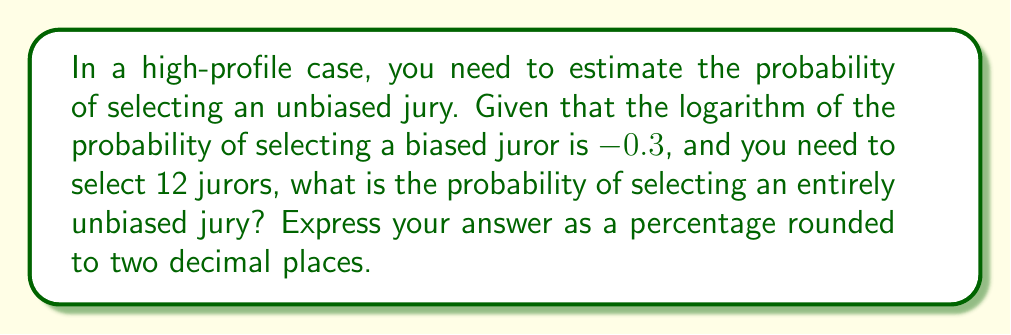Give your solution to this math problem. Let's approach this step-by-step:

1) First, we need to find the probability of selecting a biased juror. We're given that:

   $\log(P(\text{biased})) = -0.3$

2) To find $P(\text{biased})$, we need to take the antilog (inverse of log):

   $P(\text{biased}) = 10^{-0.3} \approx 0.5012$

3) The probability of selecting an unbiased juror is therefore:

   $P(\text{unbiased}) = 1 - P(\text{biased}) \approx 1 - 0.5012 = 0.4988$

4) Now, we need to find the probability of selecting 12 unbiased jurors in a row. This is a binomial probability where we want all 12 to be unbiased:

   $P(\text{all unbiased}) = (P(\text{unbiased}))^{12}$

5) Calculating this:

   $P(\text{all unbiased}) = (0.4988)^{12} \approx 0.0000265$

6) To express this as a percentage:

   $0.0000265 * 100 = 0.00265\%$

7) Rounding to two decimal places:

   $0.00\%$
Answer: $0.00\%$ 